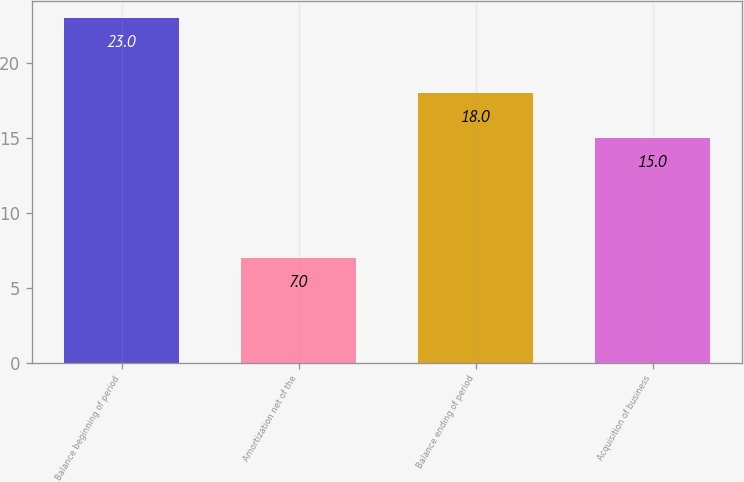<chart> <loc_0><loc_0><loc_500><loc_500><bar_chart><fcel>Balance beginning of period<fcel>Amortization net of the<fcel>Balance ending of period<fcel>Acquisition of business<nl><fcel>23<fcel>7<fcel>18<fcel>15<nl></chart> 